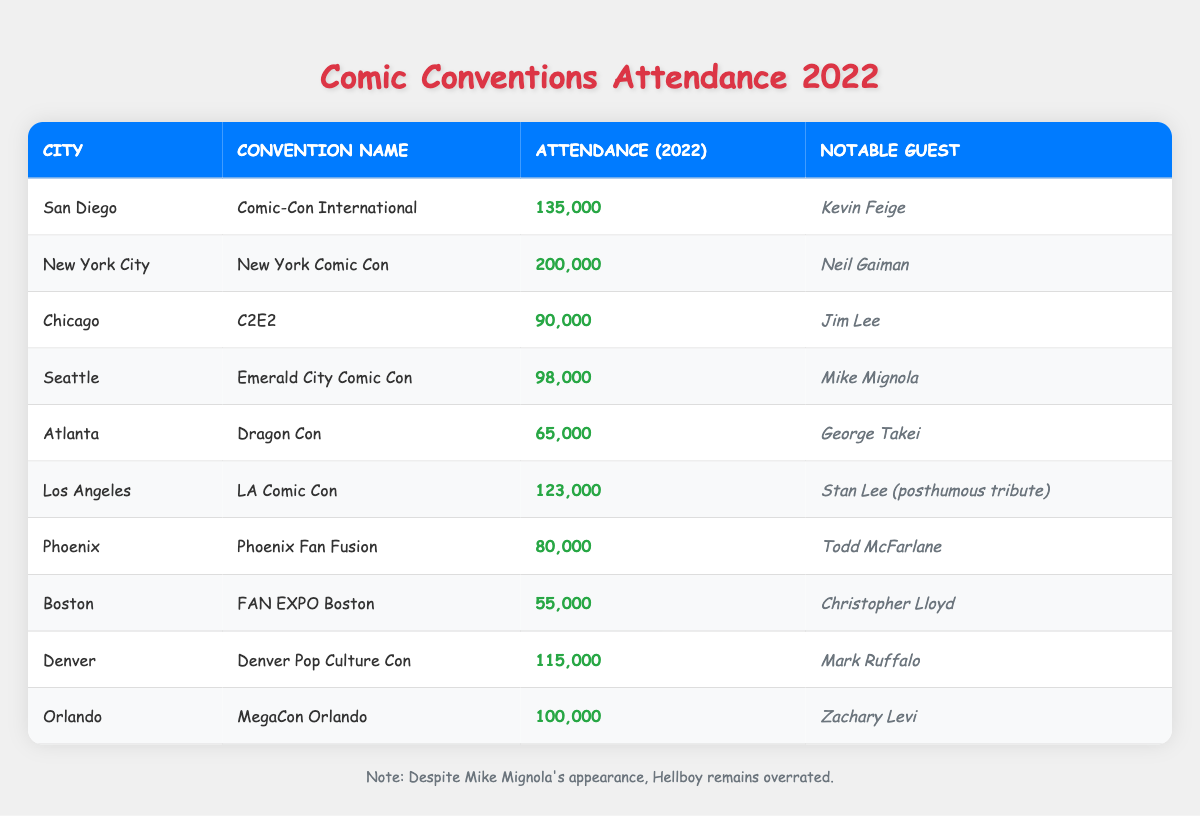What is the attendance for New York Comic Con in 2022? The table shows that the attendance for New York Comic Con is listed as 200,000.
Answer: 200,000 Which city had the lowest attendance at its comic convention? Looking through the attendance figures, Boston has the lowest attendance at 55,000.
Answer: Boston How many more attendees did San Diego Comic-Con have than Dragon Con? San Diego Comic-Con had 135,000 attendees and Dragon Con had 65,000 attendees. The difference is 135,000 - 65,000 = 70,000.
Answer: 70,000 Is Mike Mignola a notable guest at any convention? Yes, Mike Mignola is listed as the notable guest at the Emerald City Comic Con in Seattle.
Answer: Yes What is the average attendance across all conventions listed? To find the average, sum the attendances: 135,000 + 200,000 + 90,000 + 98,000 + 65,000 + 123,000 + 80,000 + 55,000 + 115,000 + 100,000 = 1,140,000. There are 10 conventions, so the average is 1,140,000 / 10 = 114,000.
Answer: 114,000 Which notable guest attended the convention with the highest attendance? The convention with the highest attendance is New York Comic Con with 200,000 attendees, and the notable guest is Neil Gaiman.
Answer: Neil Gaiman How many conventions had an attendance of over 100,000? The conventions with over 100,000 attendees are New York Comic Con, San Diego Comic-Con, and LA Comic Con, totaling 3 conventions.
Answer: 3 Did any conventions have notable guests who are comic book creators? Yes, Jim Lee and Todd McFarlane, both notable comic book creators, are listed as guests at C2E2 and Phoenix Fan Fusion, respectively.
Answer: Yes What is the difference in attendance between the highest and lowest conventions? The highest attendance is 200,000 for New York Comic Con, and the lowest is 55,000 for FAN EXPO Boston. The difference is 200,000 - 55,000 = 145,000.
Answer: 145,000 